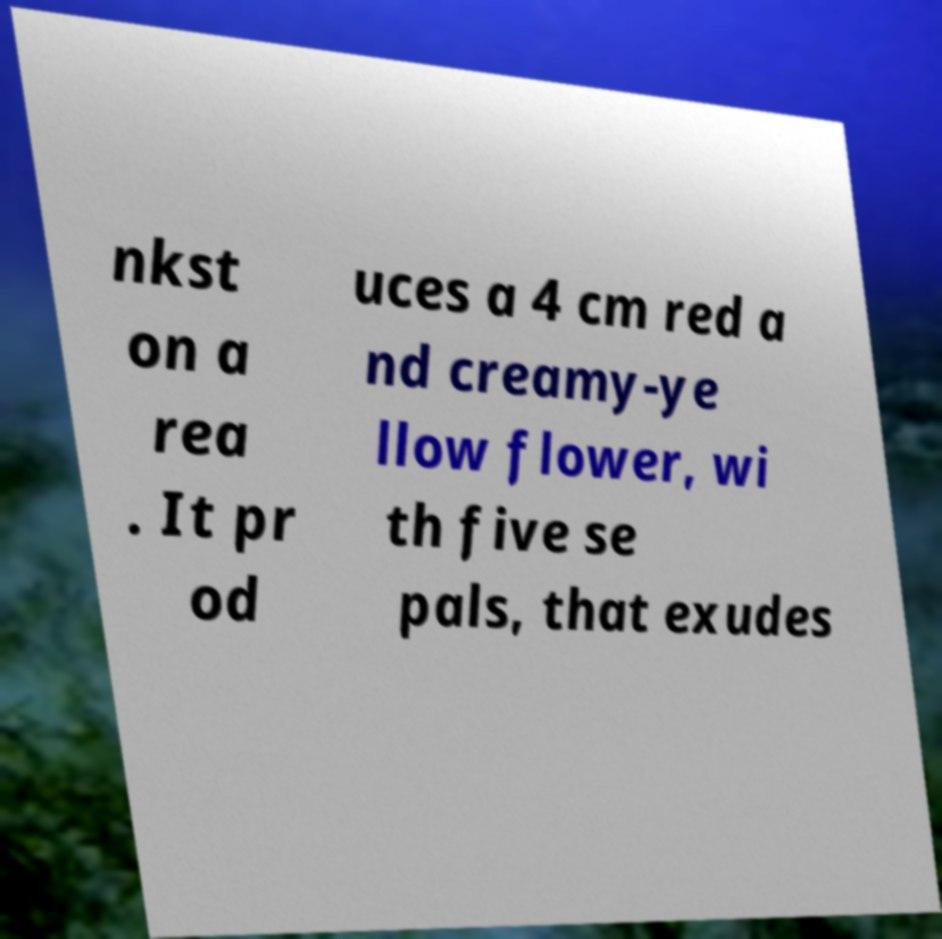Please identify and transcribe the text found in this image. nkst on a rea . It pr od uces a 4 cm red a nd creamy-ye llow flower, wi th five se pals, that exudes 